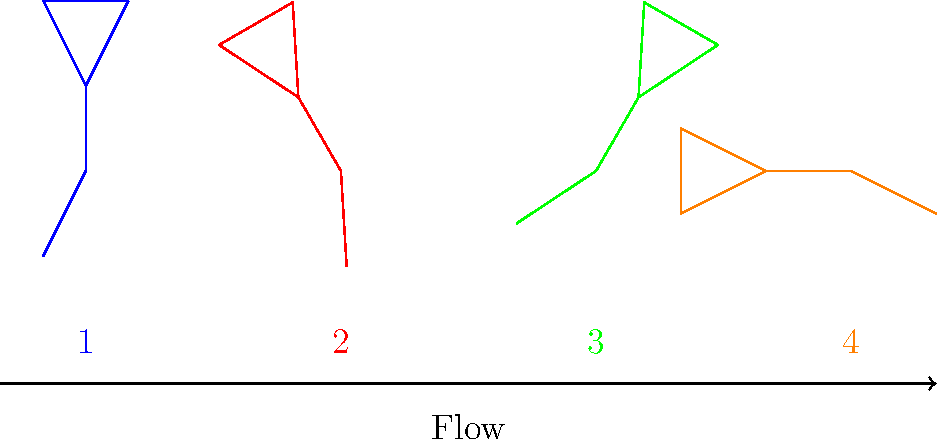In a beginner's yoga flow, which of the following sequences would be most appropriate for a smooth transition between poses? To determine the most appropriate sequence for a beginner's yoga flow, we need to consider the following principles:

1. Start with a neutral pose: The blue figure (1) represents a standing pose, which is an excellent starting point for beginners.

2. Gradual progression: Move from simpler to more complex poses gradually.

3. Balance: Alternate between different types of poses to maintain balance and prevent strain on specific muscle groups.

4. Smooth transitions: Ensure that consecutive poses flow naturally into each other.

Analyzing the poses:
1. Blue figure (1): Standing pose (neutral starting position)
2. Red figure (2): Slight forward bend
3. Green figure (3): Slight backward bend
4. Orange figure (4): Seated forward fold

The most appropriate sequence would be:

1 → 2 → 3 → 4

This sequence follows a logical progression:
- Start in a neutral standing pose (1)
- Move to a slight forward bend (2), warming up the spine and hamstrings
- Counterbalance with a slight backward bend (3), promoting flexibility and preventing strain
- End with a seated forward fold (4), which is a natural progression from the standing poses and provides a gentle stretch

This sequence allows for smooth transitions between poses and gradually increases the intensity, making it suitable for beginners.
Answer: 1 → 2 → 3 → 4 